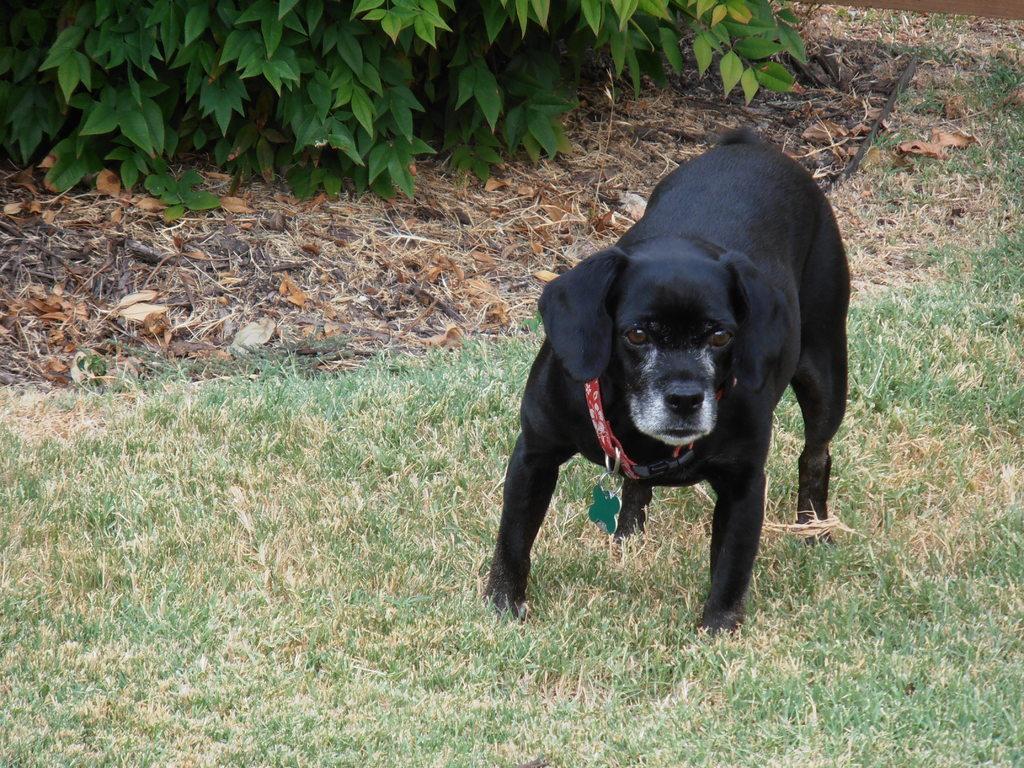How would you summarize this image in a sentence or two? In the picture there is a dog on the grass, there are plants. 